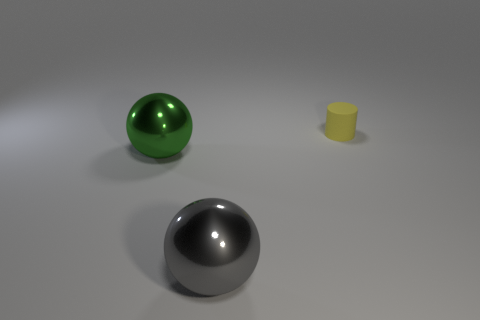Is there any indication of what these objects might be used for, or is the scene purely abstract? The scene appears to be abstract with no clear indication of function or context for the objects, focusing instead on their geometry and material properties. Could you imagine a context where these objects might naturally belong? The spheres could be artistic decorations or part of a minimalist sculpture, while the cylinder might be a simplistic representation of a container or a cup. 